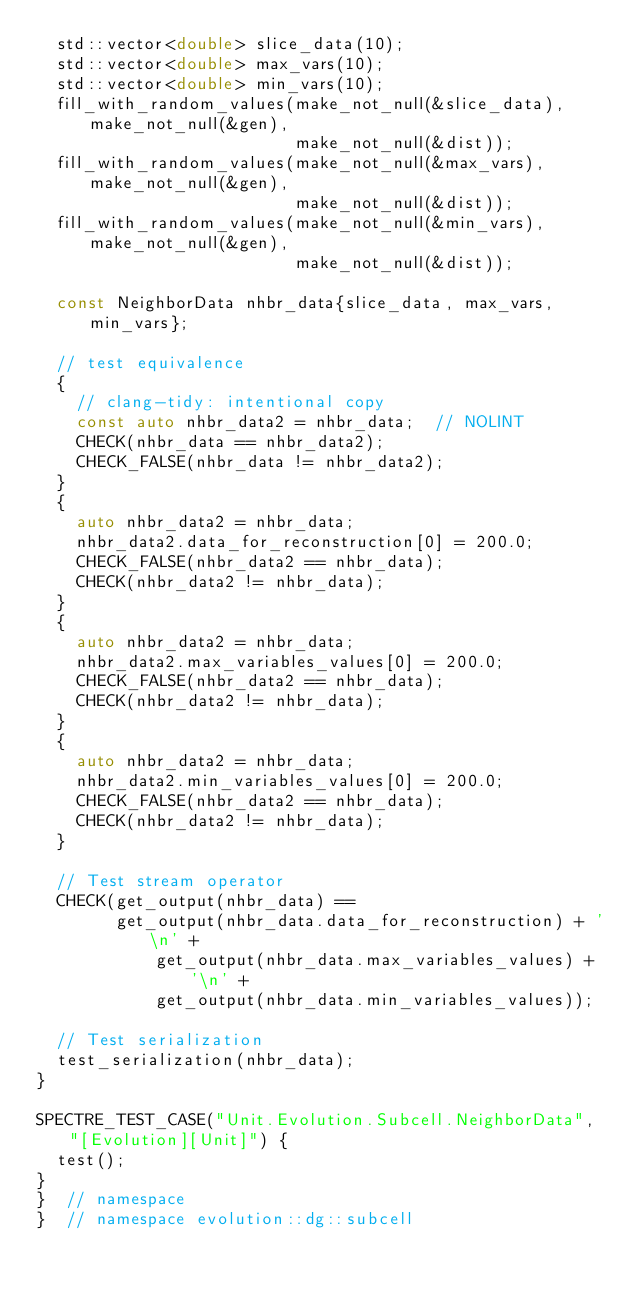Convert code to text. <code><loc_0><loc_0><loc_500><loc_500><_C++_>  std::vector<double> slice_data(10);
  std::vector<double> max_vars(10);
  std::vector<double> min_vars(10);
  fill_with_random_values(make_not_null(&slice_data), make_not_null(&gen),
                          make_not_null(&dist));
  fill_with_random_values(make_not_null(&max_vars), make_not_null(&gen),
                          make_not_null(&dist));
  fill_with_random_values(make_not_null(&min_vars), make_not_null(&gen),
                          make_not_null(&dist));

  const NeighborData nhbr_data{slice_data, max_vars, min_vars};

  // test equivalence
  {
    // clang-tidy: intentional copy
    const auto nhbr_data2 = nhbr_data;  // NOLINT
    CHECK(nhbr_data == nhbr_data2);
    CHECK_FALSE(nhbr_data != nhbr_data2);
  }
  {
    auto nhbr_data2 = nhbr_data;
    nhbr_data2.data_for_reconstruction[0] = 200.0;
    CHECK_FALSE(nhbr_data2 == nhbr_data);
    CHECK(nhbr_data2 != nhbr_data);
  }
  {
    auto nhbr_data2 = nhbr_data;
    nhbr_data2.max_variables_values[0] = 200.0;
    CHECK_FALSE(nhbr_data2 == nhbr_data);
    CHECK(nhbr_data2 != nhbr_data);
  }
  {
    auto nhbr_data2 = nhbr_data;
    nhbr_data2.min_variables_values[0] = 200.0;
    CHECK_FALSE(nhbr_data2 == nhbr_data);
    CHECK(nhbr_data2 != nhbr_data);
  }

  // Test stream operator
  CHECK(get_output(nhbr_data) ==
        get_output(nhbr_data.data_for_reconstruction) + '\n' +
            get_output(nhbr_data.max_variables_values) + '\n' +
            get_output(nhbr_data.min_variables_values));

  // Test serialization
  test_serialization(nhbr_data);
}

SPECTRE_TEST_CASE("Unit.Evolution.Subcell.NeighborData", "[Evolution][Unit]") {
  test();
}
}  // namespace
}  // namespace evolution::dg::subcell
</code> 